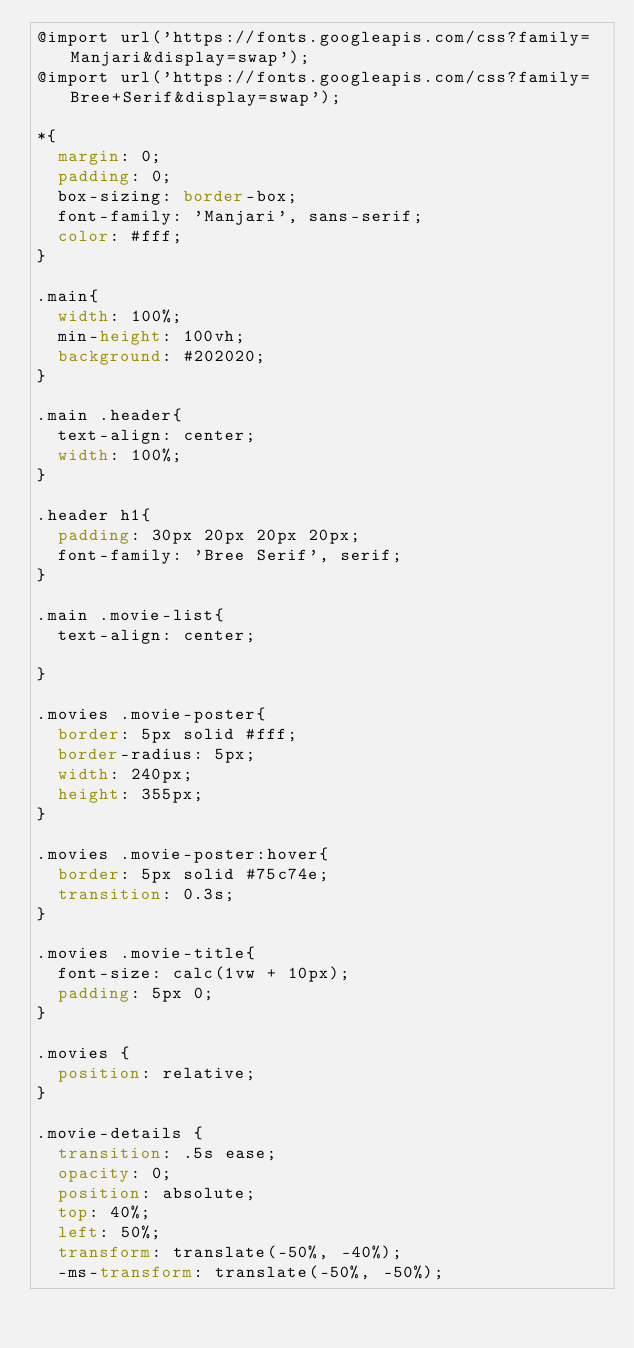Convert code to text. <code><loc_0><loc_0><loc_500><loc_500><_CSS_>@import url('https://fonts.googleapis.com/css?family=Manjari&display=swap');
@import url('https://fonts.googleapis.com/css?family=Bree+Serif&display=swap');

*{
  margin: 0;
  padding: 0;
  box-sizing: border-box;
  font-family: 'Manjari', sans-serif;
  color: #fff;
}

.main{
  width: 100%;
  min-height: 100vh;
  background: #202020;
}

.main .header{
  text-align: center;
  width: 100%;
}

.header h1{
  padding: 30px 20px 20px 20px;
  font-family: 'Bree Serif', serif;
}

.main .movie-list{
  text-align: center;

}

.movies .movie-poster{
  border: 5px solid #fff;
  border-radius: 5px;
  width: 240px;
  height: 355px;
}

.movies .movie-poster:hover{
  border: 5px solid #75c74e;
  transition: 0.3s;
}

.movies .movie-title{
  font-size: calc(1vw + 10px);
  padding: 5px 0;
}

.movies {
  position: relative;
}

.movie-details {
  transition: .5s ease;
  opacity: 0;
  position: absolute;
  top: 40%;
  left: 50%;
  transform: translate(-50%, -40%);
  -ms-transform: translate(-50%, -50%);</code> 